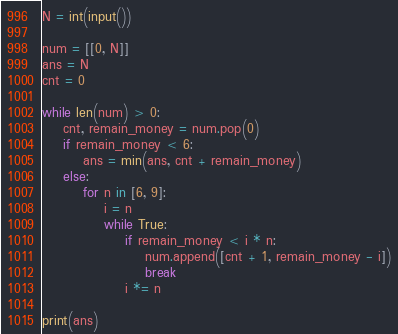Convert code to text. <code><loc_0><loc_0><loc_500><loc_500><_Python_>N = int(input())

num = [[0, N]]
ans = N
cnt = 0

while len(num) > 0:
    cnt, remain_money = num.pop(0)
    if remain_money < 6:
        ans = min(ans, cnt + remain_money)
    else:
        for n in [6, 9]:
            i = n
            while True:
                if remain_money < i * n:
                    num.append([cnt + 1, remain_money - i])
                    break
                i *= n

print(ans)</code> 